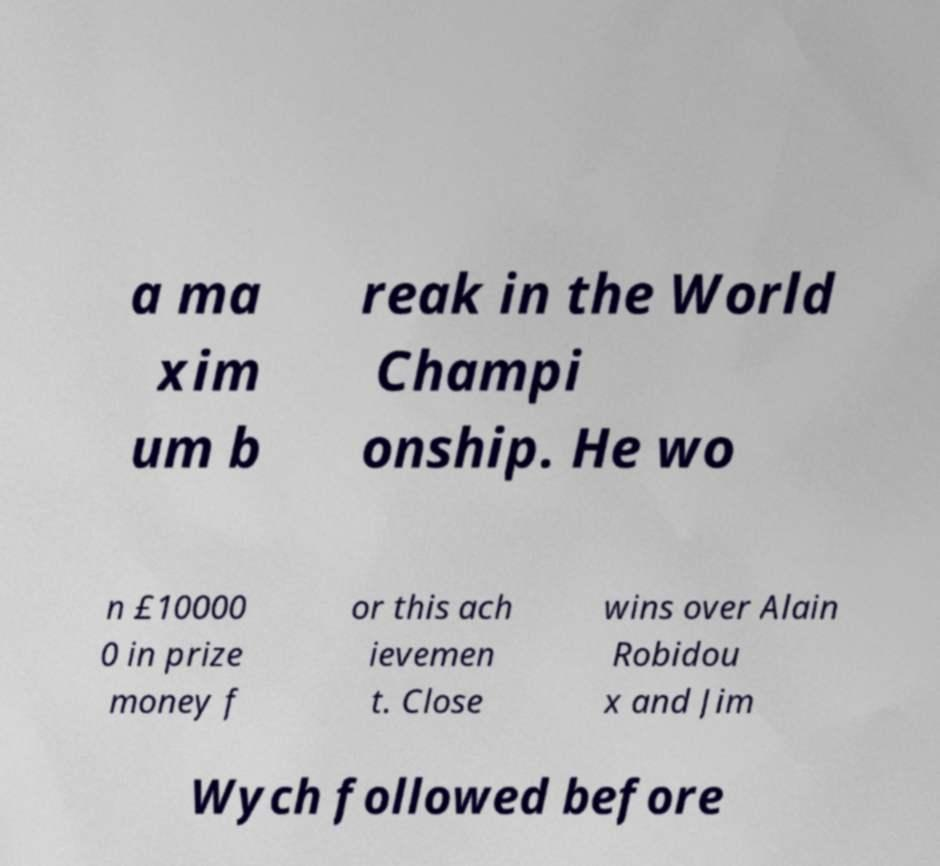Please read and relay the text visible in this image. What does it say? a ma xim um b reak in the World Champi onship. He wo n £10000 0 in prize money f or this ach ievemen t. Close wins over Alain Robidou x and Jim Wych followed before 